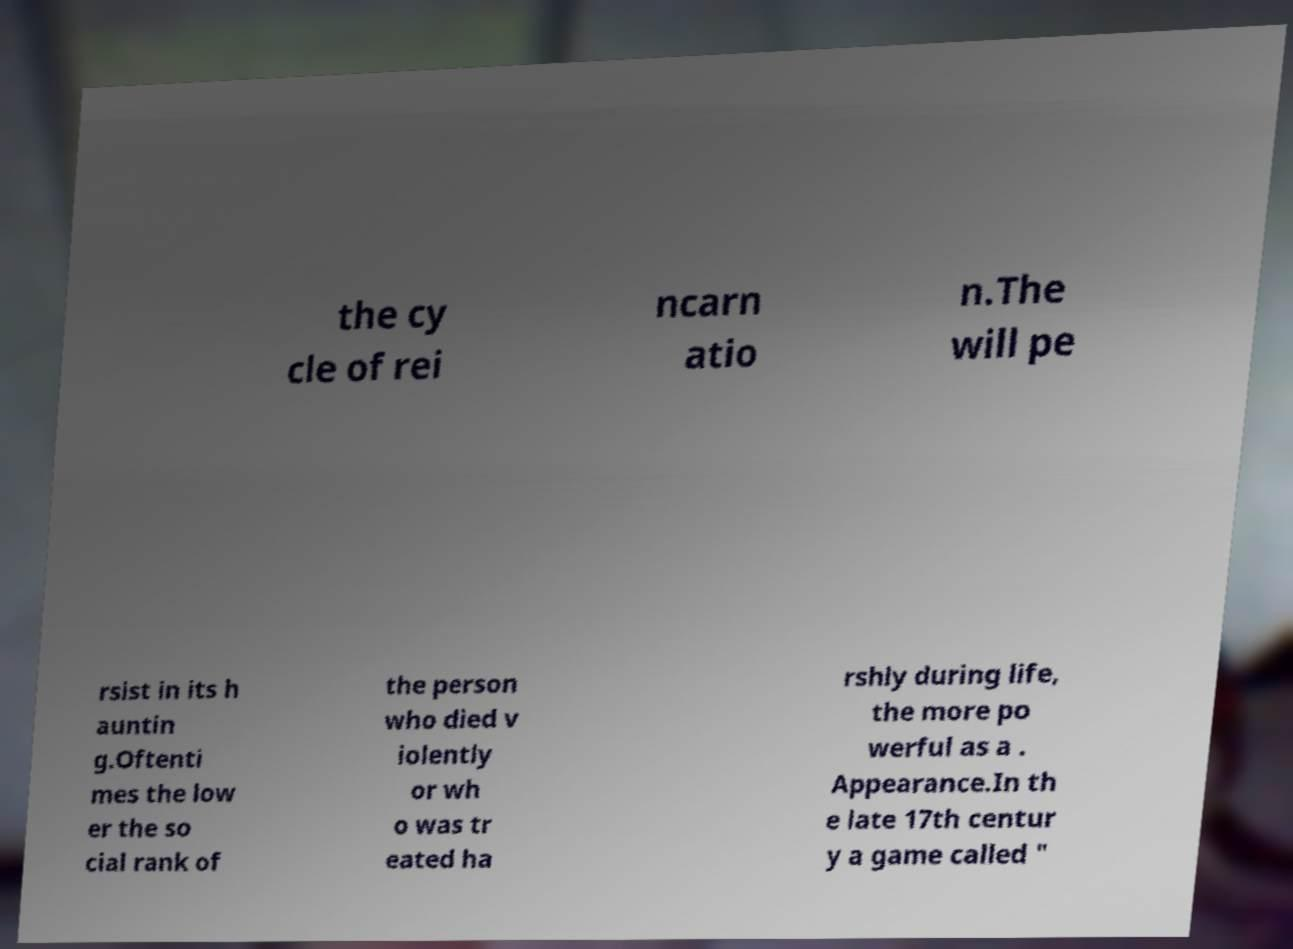Can you accurately transcribe the text from the provided image for me? the cy cle of rei ncarn atio n.The will pe rsist in its h auntin g.Oftenti mes the low er the so cial rank of the person who died v iolently or wh o was tr eated ha rshly during life, the more po werful as a . Appearance.In th e late 17th centur y a game called " 